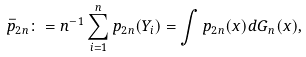Convert formula to latex. <formula><loc_0><loc_0><loc_500><loc_500>\bar { p } _ { 2 n } \colon = n ^ { - 1 } \sum _ { i = 1 } ^ { n } p _ { 2 n } ( Y _ { i } ) = \int p _ { 2 n } ( x ) d G _ { n } ( x ) ,</formula> 